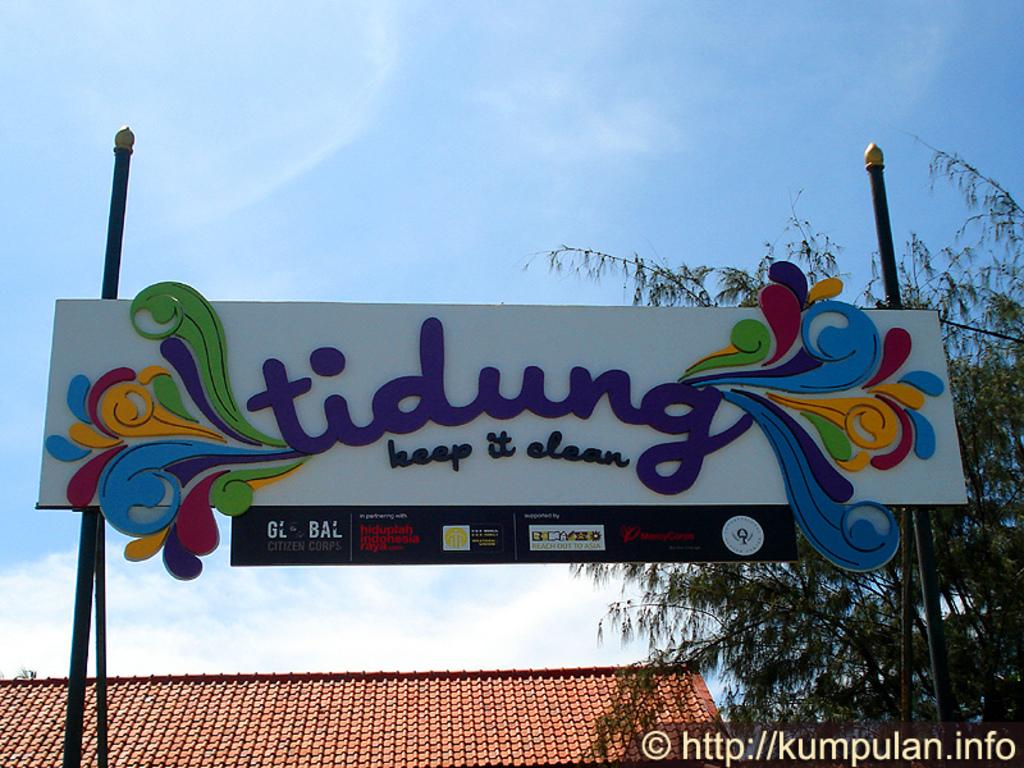<image>
Offer a succinct explanation of the picture presented. A billboard with the word "tidung" and the phrase "keep it clean" written on it with colorful graphics with a tree and tile roof in the background. 